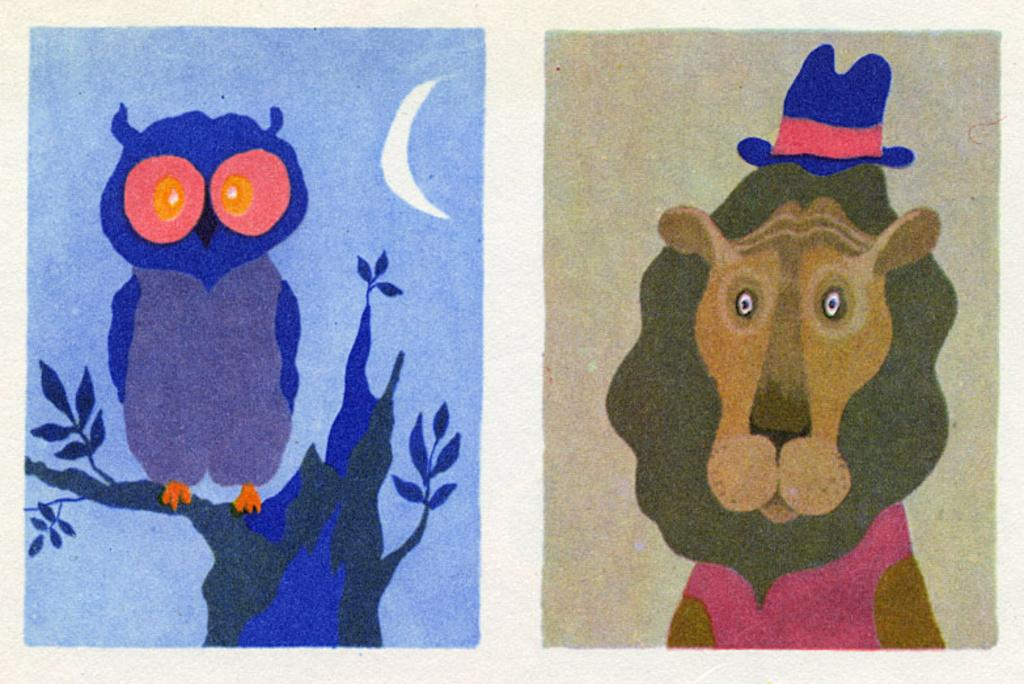What is depicted on the paper in the image? The paper contains a drawing of an owl and a lion wearing a hat. What style are the drawings in the image? The drawings are of a painting style. Where is the worm located in the image? There is no worm present in the image. What type of hall is depicted in the image? There is no hall depicted in the image; it features a paper with drawings of an owl and a lion wearing a hat. 